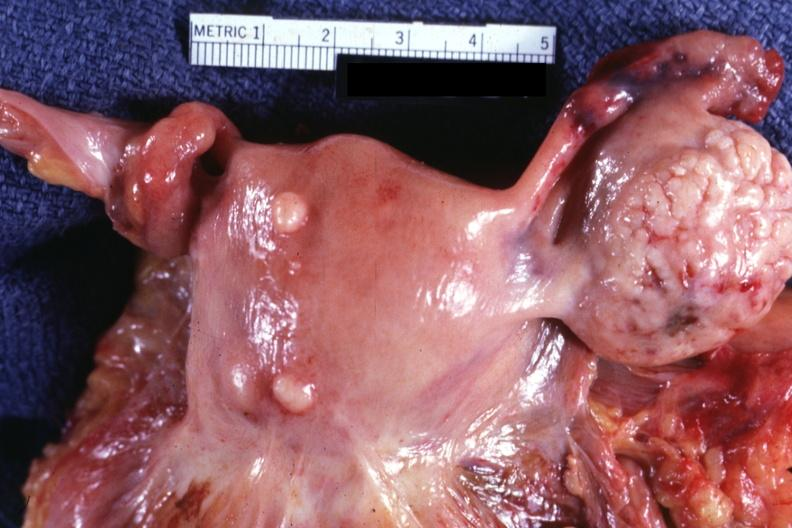how does this image show external view of uterus?
Answer the question using a single word or phrase. With two small subserosal myomas 